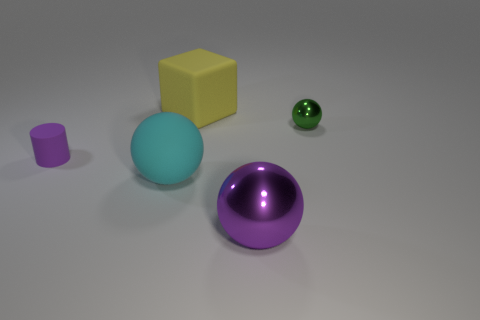Subtract all rubber balls. How many balls are left? 2 Add 5 large matte balls. How many objects exist? 10 Subtract all blocks. How many objects are left? 4 Add 4 large blocks. How many large blocks are left? 5 Add 5 big yellow matte cubes. How many big yellow matte cubes exist? 6 Subtract 1 yellow blocks. How many objects are left? 4 Subtract all tiny blue metal spheres. Subtract all matte balls. How many objects are left? 4 